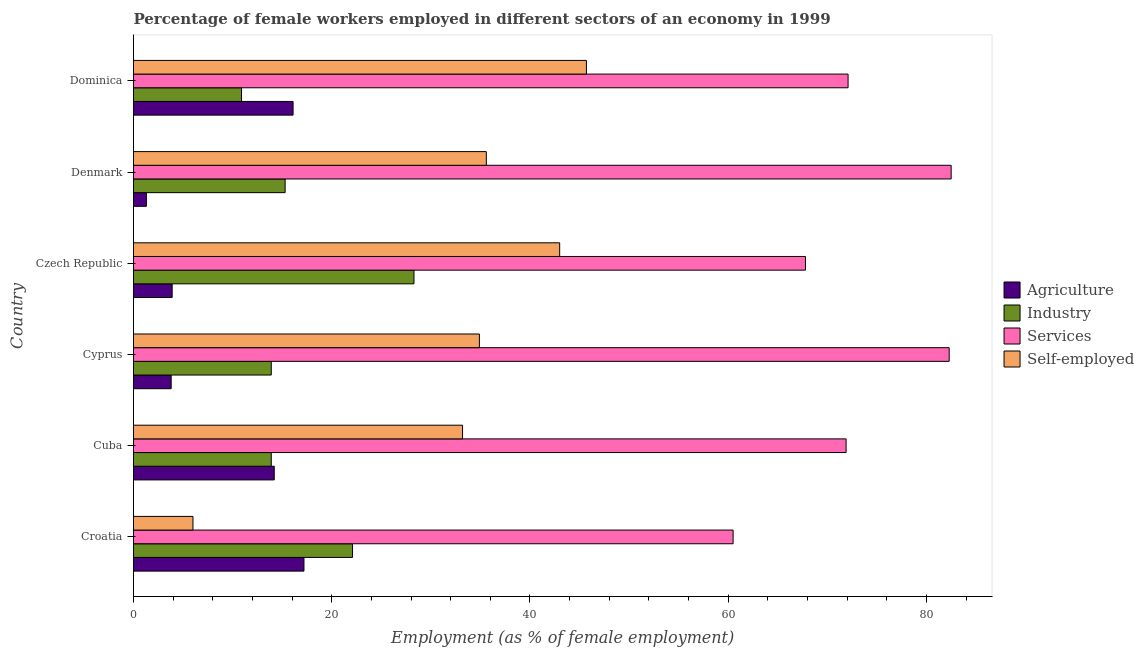Are the number of bars per tick equal to the number of legend labels?
Offer a terse response. Yes. Are the number of bars on each tick of the Y-axis equal?
Give a very brief answer. Yes. How many bars are there on the 1st tick from the bottom?
Provide a short and direct response. 4. What is the label of the 1st group of bars from the top?
Your answer should be very brief. Dominica. Across all countries, what is the maximum percentage of self employed female workers?
Offer a terse response. 45.7. Across all countries, what is the minimum percentage of female workers in industry?
Provide a succinct answer. 10.9. In which country was the percentage of female workers in agriculture maximum?
Ensure brevity in your answer.  Croatia. In which country was the percentage of self employed female workers minimum?
Keep it short and to the point. Croatia. What is the total percentage of self employed female workers in the graph?
Provide a short and direct response. 198.4. What is the difference between the percentage of female workers in industry in Cyprus and that in Denmark?
Offer a very short reply. -1.4. What is the difference between the percentage of self employed female workers in Cyprus and the percentage of female workers in industry in Denmark?
Offer a terse response. 19.6. What is the average percentage of female workers in services per country?
Ensure brevity in your answer.  72.85. What is the difference between the percentage of self employed female workers and percentage of female workers in services in Croatia?
Provide a short and direct response. -54.5. What is the ratio of the percentage of self employed female workers in Cuba to that in Cyprus?
Offer a terse response. 0.95. Is the difference between the percentage of female workers in industry in Croatia and Denmark greater than the difference between the percentage of self employed female workers in Croatia and Denmark?
Ensure brevity in your answer.  Yes. What is the difference between the highest and the second highest percentage of self employed female workers?
Your answer should be compact. 2.7. Is it the case that in every country, the sum of the percentage of female workers in industry and percentage of self employed female workers is greater than the sum of percentage of female workers in agriculture and percentage of female workers in services?
Your answer should be very brief. No. What does the 3rd bar from the top in Denmark represents?
Keep it short and to the point. Industry. What does the 2nd bar from the bottom in Cyprus represents?
Provide a succinct answer. Industry. Are all the bars in the graph horizontal?
Offer a very short reply. Yes. What is the difference between two consecutive major ticks on the X-axis?
Keep it short and to the point. 20. Does the graph contain any zero values?
Provide a succinct answer. No. What is the title of the graph?
Your answer should be compact. Percentage of female workers employed in different sectors of an economy in 1999. Does "Other expenses" appear as one of the legend labels in the graph?
Ensure brevity in your answer.  No. What is the label or title of the X-axis?
Offer a very short reply. Employment (as % of female employment). What is the Employment (as % of female employment) in Agriculture in Croatia?
Offer a very short reply. 17.2. What is the Employment (as % of female employment) of Industry in Croatia?
Your answer should be very brief. 22.1. What is the Employment (as % of female employment) of Services in Croatia?
Offer a terse response. 60.5. What is the Employment (as % of female employment) of Self-employed in Croatia?
Provide a succinct answer. 6. What is the Employment (as % of female employment) of Agriculture in Cuba?
Make the answer very short. 14.2. What is the Employment (as % of female employment) of Industry in Cuba?
Give a very brief answer. 13.9. What is the Employment (as % of female employment) in Services in Cuba?
Keep it short and to the point. 71.9. What is the Employment (as % of female employment) in Self-employed in Cuba?
Provide a short and direct response. 33.2. What is the Employment (as % of female employment) in Agriculture in Cyprus?
Keep it short and to the point. 3.8. What is the Employment (as % of female employment) in Industry in Cyprus?
Provide a succinct answer. 13.9. What is the Employment (as % of female employment) of Services in Cyprus?
Your answer should be compact. 82.3. What is the Employment (as % of female employment) in Self-employed in Cyprus?
Give a very brief answer. 34.9. What is the Employment (as % of female employment) in Agriculture in Czech Republic?
Give a very brief answer. 3.9. What is the Employment (as % of female employment) in Industry in Czech Republic?
Your answer should be very brief. 28.3. What is the Employment (as % of female employment) in Services in Czech Republic?
Ensure brevity in your answer.  67.8. What is the Employment (as % of female employment) of Self-employed in Czech Republic?
Your answer should be very brief. 43. What is the Employment (as % of female employment) in Agriculture in Denmark?
Give a very brief answer. 1.3. What is the Employment (as % of female employment) in Industry in Denmark?
Offer a terse response. 15.3. What is the Employment (as % of female employment) of Services in Denmark?
Give a very brief answer. 82.5. What is the Employment (as % of female employment) in Self-employed in Denmark?
Make the answer very short. 35.6. What is the Employment (as % of female employment) of Agriculture in Dominica?
Your answer should be compact. 16.1. What is the Employment (as % of female employment) in Industry in Dominica?
Provide a short and direct response. 10.9. What is the Employment (as % of female employment) in Services in Dominica?
Your response must be concise. 72.1. What is the Employment (as % of female employment) in Self-employed in Dominica?
Give a very brief answer. 45.7. Across all countries, what is the maximum Employment (as % of female employment) of Agriculture?
Your response must be concise. 17.2. Across all countries, what is the maximum Employment (as % of female employment) in Industry?
Your answer should be compact. 28.3. Across all countries, what is the maximum Employment (as % of female employment) in Services?
Offer a very short reply. 82.5. Across all countries, what is the maximum Employment (as % of female employment) of Self-employed?
Offer a terse response. 45.7. Across all countries, what is the minimum Employment (as % of female employment) in Agriculture?
Make the answer very short. 1.3. Across all countries, what is the minimum Employment (as % of female employment) in Industry?
Ensure brevity in your answer.  10.9. Across all countries, what is the minimum Employment (as % of female employment) in Services?
Keep it short and to the point. 60.5. What is the total Employment (as % of female employment) of Agriculture in the graph?
Give a very brief answer. 56.5. What is the total Employment (as % of female employment) in Industry in the graph?
Your answer should be compact. 104.4. What is the total Employment (as % of female employment) in Services in the graph?
Give a very brief answer. 437.1. What is the total Employment (as % of female employment) in Self-employed in the graph?
Make the answer very short. 198.4. What is the difference between the Employment (as % of female employment) in Agriculture in Croatia and that in Cuba?
Provide a short and direct response. 3. What is the difference between the Employment (as % of female employment) of Services in Croatia and that in Cuba?
Provide a short and direct response. -11.4. What is the difference between the Employment (as % of female employment) in Self-employed in Croatia and that in Cuba?
Ensure brevity in your answer.  -27.2. What is the difference between the Employment (as % of female employment) in Agriculture in Croatia and that in Cyprus?
Offer a terse response. 13.4. What is the difference between the Employment (as % of female employment) in Services in Croatia and that in Cyprus?
Give a very brief answer. -21.8. What is the difference between the Employment (as % of female employment) in Self-employed in Croatia and that in Cyprus?
Make the answer very short. -28.9. What is the difference between the Employment (as % of female employment) of Self-employed in Croatia and that in Czech Republic?
Keep it short and to the point. -37. What is the difference between the Employment (as % of female employment) of Industry in Croatia and that in Denmark?
Offer a terse response. 6.8. What is the difference between the Employment (as % of female employment) of Self-employed in Croatia and that in Denmark?
Offer a very short reply. -29.6. What is the difference between the Employment (as % of female employment) in Services in Croatia and that in Dominica?
Offer a very short reply. -11.6. What is the difference between the Employment (as % of female employment) in Self-employed in Croatia and that in Dominica?
Your answer should be very brief. -39.7. What is the difference between the Employment (as % of female employment) of Services in Cuba and that in Cyprus?
Your response must be concise. -10.4. What is the difference between the Employment (as % of female employment) in Self-employed in Cuba and that in Cyprus?
Your answer should be compact. -1.7. What is the difference between the Employment (as % of female employment) of Industry in Cuba and that in Czech Republic?
Offer a terse response. -14.4. What is the difference between the Employment (as % of female employment) in Self-employed in Cuba and that in Czech Republic?
Ensure brevity in your answer.  -9.8. What is the difference between the Employment (as % of female employment) in Services in Cuba and that in Denmark?
Your response must be concise. -10.6. What is the difference between the Employment (as % of female employment) in Self-employed in Cuba and that in Denmark?
Ensure brevity in your answer.  -2.4. What is the difference between the Employment (as % of female employment) in Services in Cuba and that in Dominica?
Offer a terse response. -0.2. What is the difference between the Employment (as % of female employment) in Self-employed in Cuba and that in Dominica?
Your answer should be compact. -12.5. What is the difference between the Employment (as % of female employment) of Agriculture in Cyprus and that in Czech Republic?
Give a very brief answer. -0.1. What is the difference between the Employment (as % of female employment) of Industry in Cyprus and that in Czech Republic?
Your answer should be very brief. -14.4. What is the difference between the Employment (as % of female employment) of Self-employed in Cyprus and that in Czech Republic?
Your answer should be compact. -8.1. What is the difference between the Employment (as % of female employment) in Agriculture in Cyprus and that in Denmark?
Provide a succinct answer. 2.5. What is the difference between the Employment (as % of female employment) in Services in Cyprus and that in Denmark?
Ensure brevity in your answer.  -0.2. What is the difference between the Employment (as % of female employment) in Industry in Cyprus and that in Dominica?
Keep it short and to the point. 3. What is the difference between the Employment (as % of female employment) of Services in Cyprus and that in Dominica?
Offer a very short reply. 10.2. What is the difference between the Employment (as % of female employment) of Agriculture in Czech Republic and that in Denmark?
Make the answer very short. 2.6. What is the difference between the Employment (as % of female employment) of Services in Czech Republic and that in Denmark?
Make the answer very short. -14.7. What is the difference between the Employment (as % of female employment) of Services in Czech Republic and that in Dominica?
Offer a very short reply. -4.3. What is the difference between the Employment (as % of female employment) of Agriculture in Denmark and that in Dominica?
Your response must be concise. -14.8. What is the difference between the Employment (as % of female employment) in Self-employed in Denmark and that in Dominica?
Give a very brief answer. -10.1. What is the difference between the Employment (as % of female employment) in Agriculture in Croatia and the Employment (as % of female employment) in Industry in Cuba?
Provide a succinct answer. 3.3. What is the difference between the Employment (as % of female employment) in Agriculture in Croatia and the Employment (as % of female employment) in Services in Cuba?
Offer a very short reply. -54.7. What is the difference between the Employment (as % of female employment) in Industry in Croatia and the Employment (as % of female employment) in Services in Cuba?
Make the answer very short. -49.8. What is the difference between the Employment (as % of female employment) of Services in Croatia and the Employment (as % of female employment) of Self-employed in Cuba?
Your response must be concise. 27.3. What is the difference between the Employment (as % of female employment) in Agriculture in Croatia and the Employment (as % of female employment) in Industry in Cyprus?
Your answer should be compact. 3.3. What is the difference between the Employment (as % of female employment) in Agriculture in Croatia and the Employment (as % of female employment) in Services in Cyprus?
Your answer should be compact. -65.1. What is the difference between the Employment (as % of female employment) of Agriculture in Croatia and the Employment (as % of female employment) of Self-employed in Cyprus?
Provide a succinct answer. -17.7. What is the difference between the Employment (as % of female employment) of Industry in Croatia and the Employment (as % of female employment) of Services in Cyprus?
Provide a short and direct response. -60.2. What is the difference between the Employment (as % of female employment) in Services in Croatia and the Employment (as % of female employment) in Self-employed in Cyprus?
Offer a very short reply. 25.6. What is the difference between the Employment (as % of female employment) in Agriculture in Croatia and the Employment (as % of female employment) in Industry in Czech Republic?
Your response must be concise. -11.1. What is the difference between the Employment (as % of female employment) in Agriculture in Croatia and the Employment (as % of female employment) in Services in Czech Republic?
Provide a succinct answer. -50.6. What is the difference between the Employment (as % of female employment) of Agriculture in Croatia and the Employment (as % of female employment) of Self-employed in Czech Republic?
Give a very brief answer. -25.8. What is the difference between the Employment (as % of female employment) of Industry in Croatia and the Employment (as % of female employment) of Services in Czech Republic?
Provide a short and direct response. -45.7. What is the difference between the Employment (as % of female employment) of Industry in Croatia and the Employment (as % of female employment) of Self-employed in Czech Republic?
Provide a short and direct response. -20.9. What is the difference between the Employment (as % of female employment) of Services in Croatia and the Employment (as % of female employment) of Self-employed in Czech Republic?
Provide a short and direct response. 17.5. What is the difference between the Employment (as % of female employment) of Agriculture in Croatia and the Employment (as % of female employment) of Services in Denmark?
Make the answer very short. -65.3. What is the difference between the Employment (as % of female employment) of Agriculture in Croatia and the Employment (as % of female employment) of Self-employed in Denmark?
Provide a short and direct response. -18.4. What is the difference between the Employment (as % of female employment) of Industry in Croatia and the Employment (as % of female employment) of Services in Denmark?
Your answer should be compact. -60.4. What is the difference between the Employment (as % of female employment) of Services in Croatia and the Employment (as % of female employment) of Self-employed in Denmark?
Ensure brevity in your answer.  24.9. What is the difference between the Employment (as % of female employment) of Agriculture in Croatia and the Employment (as % of female employment) of Industry in Dominica?
Offer a terse response. 6.3. What is the difference between the Employment (as % of female employment) in Agriculture in Croatia and the Employment (as % of female employment) in Services in Dominica?
Your response must be concise. -54.9. What is the difference between the Employment (as % of female employment) of Agriculture in Croatia and the Employment (as % of female employment) of Self-employed in Dominica?
Make the answer very short. -28.5. What is the difference between the Employment (as % of female employment) of Industry in Croatia and the Employment (as % of female employment) of Self-employed in Dominica?
Offer a very short reply. -23.6. What is the difference between the Employment (as % of female employment) of Agriculture in Cuba and the Employment (as % of female employment) of Services in Cyprus?
Keep it short and to the point. -68.1. What is the difference between the Employment (as % of female employment) of Agriculture in Cuba and the Employment (as % of female employment) of Self-employed in Cyprus?
Your answer should be compact. -20.7. What is the difference between the Employment (as % of female employment) in Industry in Cuba and the Employment (as % of female employment) in Services in Cyprus?
Ensure brevity in your answer.  -68.4. What is the difference between the Employment (as % of female employment) of Industry in Cuba and the Employment (as % of female employment) of Self-employed in Cyprus?
Keep it short and to the point. -21. What is the difference between the Employment (as % of female employment) of Agriculture in Cuba and the Employment (as % of female employment) of Industry in Czech Republic?
Make the answer very short. -14.1. What is the difference between the Employment (as % of female employment) in Agriculture in Cuba and the Employment (as % of female employment) in Services in Czech Republic?
Keep it short and to the point. -53.6. What is the difference between the Employment (as % of female employment) of Agriculture in Cuba and the Employment (as % of female employment) of Self-employed in Czech Republic?
Keep it short and to the point. -28.8. What is the difference between the Employment (as % of female employment) of Industry in Cuba and the Employment (as % of female employment) of Services in Czech Republic?
Your answer should be very brief. -53.9. What is the difference between the Employment (as % of female employment) of Industry in Cuba and the Employment (as % of female employment) of Self-employed in Czech Republic?
Your answer should be compact. -29.1. What is the difference between the Employment (as % of female employment) of Services in Cuba and the Employment (as % of female employment) of Self-employed in Czech Republic?
Make the answer very short. 28.9. What is the difference between the Employment (as % of female employment) in Agriculture in Cuba and the Employment (as % of female employment) in Industry in Denmark?
Provide a succinct answer. -1.1. What is the difference between the Employment (as % of female employment) in Agriculture in Cuba and the Employment (as % of female employment) in Services in Denmark?
Offer a terse response. -68.3. What is the difference between the Employment (as % of female employment) in Agriculture in Cuba and the Employment (as % of female employment) in Self-employed in Denmark?
Your answer should be very brief. -21.4. What is the difference between the Employment (as % of female employment) in Industry in Cuba and the Employment (as % of female employment) in Services in Denmark?
Provide a short and direct response. -68.6. What is the difference between the Employment (as % of female employment) of Industry in Cuba and the Employment (as % of female employment) of Self-employed in Denmark?
Give a very brief answer. -21.7. What is the difference between the Employment (as % of female employment) in Services in Cuba and the Employment (as % of female employment) in Self-employed in Denmark?
Make the answer very short. 36.3. What is the difference between the Employment (as % of female employment) in Agriculture in Cuba and the Employment (as % of female employment) in Services in Dominica?
Provide a succinct answer. -57.9. What is the difference between the Employment (as % of female employment) of Agriculture in Cuba and the Employment (as % of female employment) of Self-employed in Dominica?
Offer a terse response. -31.5. What is the difference between the Employment (as % of female employment) of Industry in Cuba and the Employment (as % of female employment) of Services in Dominica?
Your answer should be very brief. -58.2. What is the difference between the Employment (as % of female employment) in Industry in Cuba and the Employment (as % of female employment) in Self-employed in Dominica?
Make the answer very short. -31.8. What is the difference between the Employment (as % of female employment) of Services in Cuba and the Employment (as % of female employment) of Self-employed in Dominica?
Make the answer very short. 26.2. What is the difference between the Employment (as % of female employment) in Agriculture in Cyprus and the Employment (as % of female employment) in Industry in Czech Republic?
Offer a terse response. -24.5. What is the difference between the Employment (as % of female employment) of Agriculture in Cyprus and the Employment (as % of female employment) of Services in Czech Republic?
Your answer should be very brief. -64. What is the difference between the Employment (as % of female employment) of Agriculture in Cyprus and the Employment (as % of female employment) of Self-employed in Czech Republic?
Offer a very short reply. -39.2. What is the difference between the Employment (as % of female employment) in Industry in Cyprus and the Employment (as % of female employment) in Services in Czech Republic?
Offer a very short reply. -53.9. What is the difference between the Employment (as % of female employment) in Industry in Cyprus and the Employment (as % of female employment) in Self-employed in Czech Republic?
Your answer should be compact. -29.1. What is the difference between the Employment (as % of female employment) of Services in Cyprus and the Employment (as % of female employment) of Self-employed in Czech Republic?
Offer a terse response. 39.3. What is the difference between the Employment (as % of female employment) in Agriculture in Cyprus and the Employment (as % of female employment) in Industry in Denmark?
Offer a terse response. -11.5. What is the difference between the Employment (as % of female employment) in Agriculture in Cyprus and the Employment (as % of female employment) in Services in Denmark?
Provide a succinct answer. -78.7. What is the difference between the Employment (as % of female employment) in Agriculture in Cyprus and the Employment (as % of female employment) in Self-employed in Denmark?
Provide a succinct answer. -31.8. What is the difference between the Employment (as % of female employment) in Industry in Cyprus and the Employment (as % of female employment) in Services in Denmark?
Provide a short and direct response. -68.6. What is the difference between the Employment (as % of female employment) in Industry in Cyprus and the Employment (as % of female employment) in Self-employed in Denmark?
Keep it short and to the point. -21.7. What is the difference between the Employment (as % of female employment) of Services in Cyprus and the Employment (as % of female employment) of Self-employed in Denmark?
Your answer should be compact. 46.7. What is the difference between the Employment (as % of female employment) of Agriculture in Cyprus and the Employment (as % of female employment) of Industry in Dominica?
Ensure brevity in your answer.  -7.1. What is the difference between the Employment (as % of female employment) in Agriculture in Cyprus and the Employment (as % of female employment) in Services in Dominica?
Offer a very short reply. -68.3. What is the difference between the Employment (as % of female employment) of Agriculture in Cyprus and the Employment (as % of female employment) of Self-employed in Dominica?
Offer a terse response. -41.9. What is the difference between the Employment (as % of female employment) in Industry in Cyprus and the Employment (as % of female employment) in Services in Dominica?
Keep it short and to the point. -58.2. What is the difference between the Employment (as % of female employment) in Industry in Cyprus and the Employment (as % of female employment) in Self-employed in Dominica?
Provide a succinct answer. -31.8. What is the difference between the Employment (as % of female employment) in Services in Cyprus and the Employment (as % of female employment) in Self-employed in Dominica?
Your response must be concise. 36.6. What is the difference between the Employment (as % of female employment) of Agriculture in Czech Republic and the Employment (as % of female employment) of Industry in Denmark?
Give a very brief answer. -11.4. What is the difference between the Employment (as % of female employment) in Agriculture in Czech Republic and the Employment (as % of female employment) in Services in Denmark?
Keep it short and to the point. -78.6. What is the difference between the Employment (as % of female employment) of Agriculture in Czech Republic and the Employment (as % of female employment) of Self-employed in Denmark?
Keep it short and to the point. -31.7. What is the difference between the Employment (as % of female employment) of Industry in Czech Republic and the Employment (as % of female employment) of Services in Denmark?
Your answer should be compact. -54.2. What is the difference between the Employment (as % of female employment) of Industry in Czech Republic and the Employment (as % of female employment) of Self-employed in Denmark?
Make the answer very short. -7.3. What is the difference between the Employment (as % of female employment) of Services in Czech Republic and the Employment (as % of female employment) of Self-employed in Denmark?
Provide a succinct answer. 32.2. What is the difference between the Employment (as % of female employment) of Agriculture in Czech Republic and the Employment (as % of female employment) of Industry in Dominica?
Ensure brevity in your answer.  -7. What is the difference between the Employment (as % of female employment) in Agriculture in Czech Republic and the Employment (as % of female employment) in Services in Dominica?
Your answer should be very brief. -68.2. What is the difference between the Employment (as % of female employment) in Agriculture in Czech Republic and the Employment (as % of female employment) in Self-employed in Dominica?
Your answer should be very brief. -41.8. What is the difference between the Employment (as % of female employment) of Industry in Czech Republic and the Employment (as % of female employment) of Services in Dominica?
Offer a terse response. -43.8. What is the difference between the Employment (as % of female employment) in Industry in Czech Republic and the Employment (as % of female employment) in Self-employed in Dominica?
Your answer should be compact. -17.4. What is the difference between the Employment (as % of female employment) in Services in Czech Republic and the Employment (as % of female employment) in Self-employed in Dominica?
Ensure brevity in your answer.  22.1. What is the difference between the Employment (as % of female employment) in Agriculture in Denmark and the Employment (as % of female employment) in Services in Dominica?
Ensure brevity in your answer.  -70.8. What is the difference between the Employment (as % of female employment) of Agriculture in Denmark and the Employment (as % of female employment) of Self-employed in Dominica?
Provide a succinct answer. -44.4. What is the difference between the Employment (as % of female employment) of Industry in Denmark and the Employment (as % of female employment) of Services in Dominica?
Provide a succinct answer. -56.8. What is the difference between the Employment (as % of female employment) in Industry in Denmark and the Employment (as % of female employment) in Self-employed in Dominica?
Ensure brevity in your answer.  -30.4. What is the difference between the Employment (as % of female employment) of Services in Denmark and the Employment (as % of female employment) of Self-employed in Dominica?
Keep it short and to the point. 36.8. What is the average Employment (as % of female employment) of Agriculture per country?
Make the answer very short. 9.42. What is the average Employment (as % of female employment) of Services per country?
Give a very brief answer. 72.85. What is the average Employment (as % of female employment) in Self-employed per country?
Provide a succinct answer. 33.07. What is the difference between the Employment (as % of female employment) of Agriculture and Employment (as % of female employment) of Industry in Croatia?
Your answer should be very brief. -4.9. What is the difference between the Employment (as % of female employment) in Agriculture and Employment (as % of female employment) in Services in Croatia?
Provide a short and direct response. -43.3. What is the difference between the Employment (as % of female employment) of Agriculture and Employment (as % of female employment) of Self-employed in Croatia?
Your answer should be compact. 11.2. What is the difference between the Employment (as % of female employment) of Industry and Employment (as % of female employment) of Services in Croatia?
Give a very brief answer. -38.4. What is the difference between the Employment (as % of female employment) of Services and Employment (as % of female employment) of Self-employed in Croatia?
Give a very brief answer. 54.5. What is the difference between the Employment (as % of female employment) of Agriculture and Employment (as % of female employment) of Services in Cuba?
Provide a short and direct response. -57.7. What is the difference between the Employment (as % of female employment) of Industry and Employment (as % of female employment) of Services in Cuba?
Your answer should be compact. -58. What is the difference between the Employment (as % of female employment) in Industry and Employment (as % of female employment) in Self-employed in Cuba?
Your response must be concise. -19.3. What is the difference between the Employment (as % of female employment) of Services and Employment (as % of female employment) of Self-employed in Cuba?
Provide a succinct answer. 38.7. What is the difference between the Employment (as % of female employment) of Agriculture and Employment (as % of female employment) of Industry in Cyprus?
Your response must be concise. -10.1. What is the difference between the Employment (as % of female employment) in Agriculture and Employment (as % of female employment) in Services in Cyprus?
Your answer should be very brief. -78.5. What is the difference between the Employment (as % of female employment) in Agriculture and Employment (as % of female employment) in Self-employed in Cyprus?
Offer a terse response. -31.1. What is the difference between the Employment (as % of female employment) in Industry and Employment (as % of female employment) in Services in Cyprus?
Your answer should be compact. -68.4. What is the difference between the Employment (as % of female employment) of Services and Employment (as % of female employment) of Self-employed in Cyprus?
Your answer should be very brief. 47.4. What is the difference between the Employment (as % of female employment) in Agriculture and Employment (as % of female employment) in Industry in Czech Republic?
Provide a succinct answer. -24.4. What is the difference between the Employment (as % of female employment) of Agriculture and Employment (as % of female employment) of Services in Czech Republic?
Your answer should be very brief. -63.9. What is the difference between the Employment (as % of female employment) in Agriculture and Employment (as % of female employment) in Self-employed in Czech Republic?
Your answer should be compact. -39.1. What is the difference between the Employment (as % of female employment) in Industry and Employment (as % of female employment) in Services in Czech Republic?
Keep it short and to the point. -39.5. What is the difference between the Employment (as % of female employment) of Industry and Employment (as % of female employment) of Self-employed in Czech Republic?
Keep it short and to the point. -14.7. What is the difference between the Employment (as % of female employment) of Services and Employment (as % of female employment) of Self-employed in Czech Republic?
Provide a succinct answer. 24.8. What is the difference between the Employment (as % of female employment) of Agriculture and Employment (as % of female employment) of Industry in Denmark?
Offer a terse response. -14. What is the difference between the Employment (as % of female employment) in Agriculture and Employment (as % of female employment) in Services in Denmark?
Make the answer very short. -81.2. What is the difference between the Employment (as % of female employment) in Agriculture and Employment (as % of female employment) in Self-employed in Denmark?
Your response must be concise. -34.3. What is the difference between the Employment (as % of female employment) of Industry and Employment (as % of female employment) of Services in Denmark?
Provide a short and direct response. -67.2. What is the difference between the Employment (as % of female employment) of Industry and Employment (as % of female employment) of Self-employed in Denmark?
Ensure brevity in your answer.  -20.3. What is the difference between the Employment (as % of female employment) of Services and Employment (as % of female employment) of Self-employed in Denmark?
Provide a succinct answer. 46.9. What is the difference between the Employment (as % of female employment) of Agriculture and Employment (as % of female employment) of Industry in Dominica?
Your response must be concise. 5.2. What is the difference between the Employment (as % of female employment) in Agriculture and Employment (as % of female employment) in Services in Dominica?
Provide a short and direct response. -56. What is the difference between the Employment (as % of female employment) in Agriculture and Employment (as % of female employment) in Self-employed in Dominica?
Make the answer very short. -29.6. What is the difference between the Employment (as % of female employment) of Industry and Employment (as % of female employment) of Services in Dominica?
Your answer should be compact. -61.2. What is the difference between the Employment (as % of female employment) of Industry and Employment (as % of female employment) of Self-employed in Dominica?
Ensure brevity in your answer.  -34.8. What is the difference between the Employment (as % of female employment) in Services and Employment (as % of female employment) in Self-employed in Dominica?
Offer a very short reply. 26.4. What is the ratio of the Employment (as % of female employment) in Agriculture in Croatia to that in Cuba?
Offer a very short reply. 1.21. What is the ratio of the Employment (as % of female employment) in Industry in Croatia to that in Cuba?
Offer a very short reply. 1.59. What is the ratio of the Employment (as % of female employment) in Services in Croatia to that in Cuba?
Keep it short and to the point. 0.84. What is the ratio of the Employment (as % of female employment) of Self-employed in Croatia to that in Cuba?
Offer a terse response. 0.18. What is the ratio of the Employment (as % of female employment) of Agriculture in Croatia to that in Cyprus?
Your answer should be very brief. 4.53. What is the ratio of the Employment (as % of female employment) of Industry in Croatia to that in Cyprus?
Give a very brief answer. 1.59. What is the ratio of the Employment (as % of female employment) of Services in Croatia to that in Cyprus?
Keep it short and to the point. 0.74. What is the ratio of the Employment (as % of female employment) in Self-employed in Croatia to that in Cyprus?
Offer a very short reply. 0.17. What is the ratio of the Employment (as % of female employment) in Agriculture in Croatia to that in Czech Republic?
Ensure brevity in your answer.  4.41. What is the ratio of the Employment (as % of female employment) in Industry in Croatia to that in Czech Republic?
Offer a very short reply. 0.78. What is the ratio of the Employment (as % of female employment) of Services in Croatia to that in Czech Republic?
Keep it short and to the point. 0.89. What is the ratio of the Employment (as % of female employment) of Self-employed in Croatia to that in Czech Republic?
Make the answer very short. 0.14. What is the ratio of the Employment (as % of female employment) of Agriculture in Croatia to that in Denmark?
Provide a short and direct response. 13.23. What is the ratio of the Employment (as % of female employment) in Industry in Croatia to that in Denmark?
Offer a terse response. 1.44. What is the ratio of the Employment (as % of female employment) in Services in Croatia to that in Denmark?
Your answer should be very brief. 0.73. What is the ratio of the Employment (as % of female employment) of Self-employed in Croatia to that in Denmark?
Make the answer very short. 0.17. What is the ratio of the Employment (as % of female employment) of Agriculture in Croatia to that in Dominica?
Ensure brevity in your answer.  1.07. What is the ratio of the Employment (as % of female employment) in Industry in Croatia to that in Dominica?
Provide a succinct answer. 2.03. What is the ratio of the Employment (as % of female employment) in Services in Croatia to that in Dominica?
Make the answer very short. 0.84. What is the ratio of the Employment (as % of female employment) of Self-employed in Croatia to that in Dominica?
Provide a short and direct response. 0.13. What is the ratio of the Employment (as % of female employment) of Agriculture in Cuba to that in Cyprus?
Your response must be concise. 3.74. What is the ratio of the Employment (as % of female employment) of Services in Cuba to that in Cyprus?
Offer a terse response. 0.87. What is the ratio of the Employment (as % of female employment) in Self-employed in Cuba to that in Cyprus?
Offer a terse response. 0.95. What is the ratio of the Employment (as % of female employment) of Agriculture in Cuba to that in Czech Republic?
Provide a succinct answer. 3.64. What is the ratio of the Employment (as % of female employment) of Industry in Cuba to that in Czech Republic?
Offer a very short reply. 0.49. What is the ratio of the Employment (as % of female employment) of Services in Cuba to that in Czech Republic?
Your response must be concise. 1.06. What is the ratio of the Employment (as % of female employment) in Self-employed in Cuba to that in Czech Republic?
Give a very brief answer. 0.77. What is the ratio of the Employment (as % of female employment) of Agriculture in Cuba to that in Denmark?
Your answer should be compact. 10.92. What is the ratio of the Employment (as % of female employment) in Industry in Cuba to that in Denmark?
Offer a terse response. 0.91. What is the ratio of the Employment (as % of female employment) in Services in Cuba to that in Denmark?
Your response must be concise. 0.87. What is the ratio of the Employment (as % of female employment) in Self-employed in Cuba to that in Denmark?
Give a very brief answer. 0.93. What is the ratio of the Employment (as % of female employment) in Agriculture in Cuba to that in Dominica?
Give a very brief answer. 0.88. What is the ratio of the Employment (as % of female employment) in Industry in Cuba to that in Dominica?
Make the answer very short. 1.28. What is the ratio of the Employment (as % of female employment) in Services in Cuba to that in Dominica?
Offer a terse response. 1. What is the ratio of the Employment (as % of female employment) of Self-employed in Cuba to that in Dominica?
Your answer should be very brief. 0.73. What is the ratio of the Employment (as % of female employment) of Agriculture in Cyprus to that in Czech Republic?
Provide a succinct answer. 0.97. What is the ratio of the Employment (as % of female employment) of Industry in Cyprus to that in Czech Republic?
Your answer should be very brief. 0.49. What is the ratio of the Employment (as % of female employment) of Services in Cyprus to that in Czech Republic?
Offer a terse response. 1.21. What is the ratio of the Employment (as % of female employment) of Self-employed in Cyprus to that in Czech Republic?
Provide a short and direct response. 0.81. What is the ratio of the Employment (as % of female employment) of Agriculture in Cyprus to that in Denmark?
Your response must be concise. 2.92. What is the ratio of the Employment (as % of female employment) in Industry in Cyprus to that in Denmark?
Your answer should be compact. 0.91. What is the ratio of the Employment (as % of female employment) in Services in Cyprus to that in Denmark?
Offer a very short reply. 1. What is the ratio of the Employment (as % of female employment) in Self-employed in Cyprus to that in Denmark?
Make the answer very short. 0.98. What is the ratio of the Employment (as % of female employment) of Agriculture in Cyprus to that in Dominica?
Your answer should be very brief. 0.24. What is the ratio of the Employment (as % of female employment) of Industry in Cyprus to that in Dominica?
Ensure brevity in your answer.  1.28. What is the ratio of the Employment (as % of female employment) in Services in Cyprus to that in Dominica?
Give a very brief answer. 1.14. What is the ratio of the Employment (as % of female employment) of Self-employed in Cyprus to that in Dominica?
Your response must be concise. 0.76. What is the ratio of the Employment (as % of female employment) of Industry in Czech Republic to that in Denmark?
Offer a terse response. 1.85. What is the ratio of the Employment (as % of female employment) of Services in Czech Republic to that in Denmark?
Your answer should be compact. 0.82. What is the ratio of the Employment (as % of female employment) in Self-employed in Czech Republic to that in Denmark?
Provide a succinct answer. 1.21. What is the ratio of the Employment (as % of female employment) of Agriculture in Czech Republic to that in Dominica?
Your answer should be very brief. 0.24. What is the ratio of the Employment (as % of female employment) of Industry in Czech Republic to that in Dominica?
Ensure brevity in your answer.  2.6. What is the ratio of the Employment (as % of female employment) in Services in Czech Republic to that in Dominica?
Provide a succinct answer. 0.94. What is the ratio of the Employment (as % of female employment) of Self-employed in Czech Republic to that in Dominica?
Offer a terse response. 0.94. What is the ratio of the Employment (as % of female employment) of Agriculture in Denmark to that in Dominica?
Keep it short and to the point. 0.08. What is the ratio of the Employment (as % of female employment) of Industry in Denmark to that in Dominica?
Give a very brief answer. 1.4. What is the ratio of the Employment (as % of female employment) in Services in Denmark to that in Dominica?
Keep it short and to the point. 1.14. What is the ratio of the Employment (as % of female employment) of Self-employed in Denmark to that in Dominica?
Your answer should be very brief. 0.78. What is the difference between the highest and the second highest Employment (as % of female employment) in Industry?
Provide a short and direct response. 6.2. What is the difference between the highest and the lowest Employment (as % of female employment) in Agriculture?
Offer a terse response. 15.9. What is the difference between the highest and the lowest Employment (as % of female employment) of Industry?
Your answer should be compact. 17.4. What is the difference between the highest and the lowest Employment (as % of female employment) in Self-employed?
Your answer should be very brief. 39.7. 